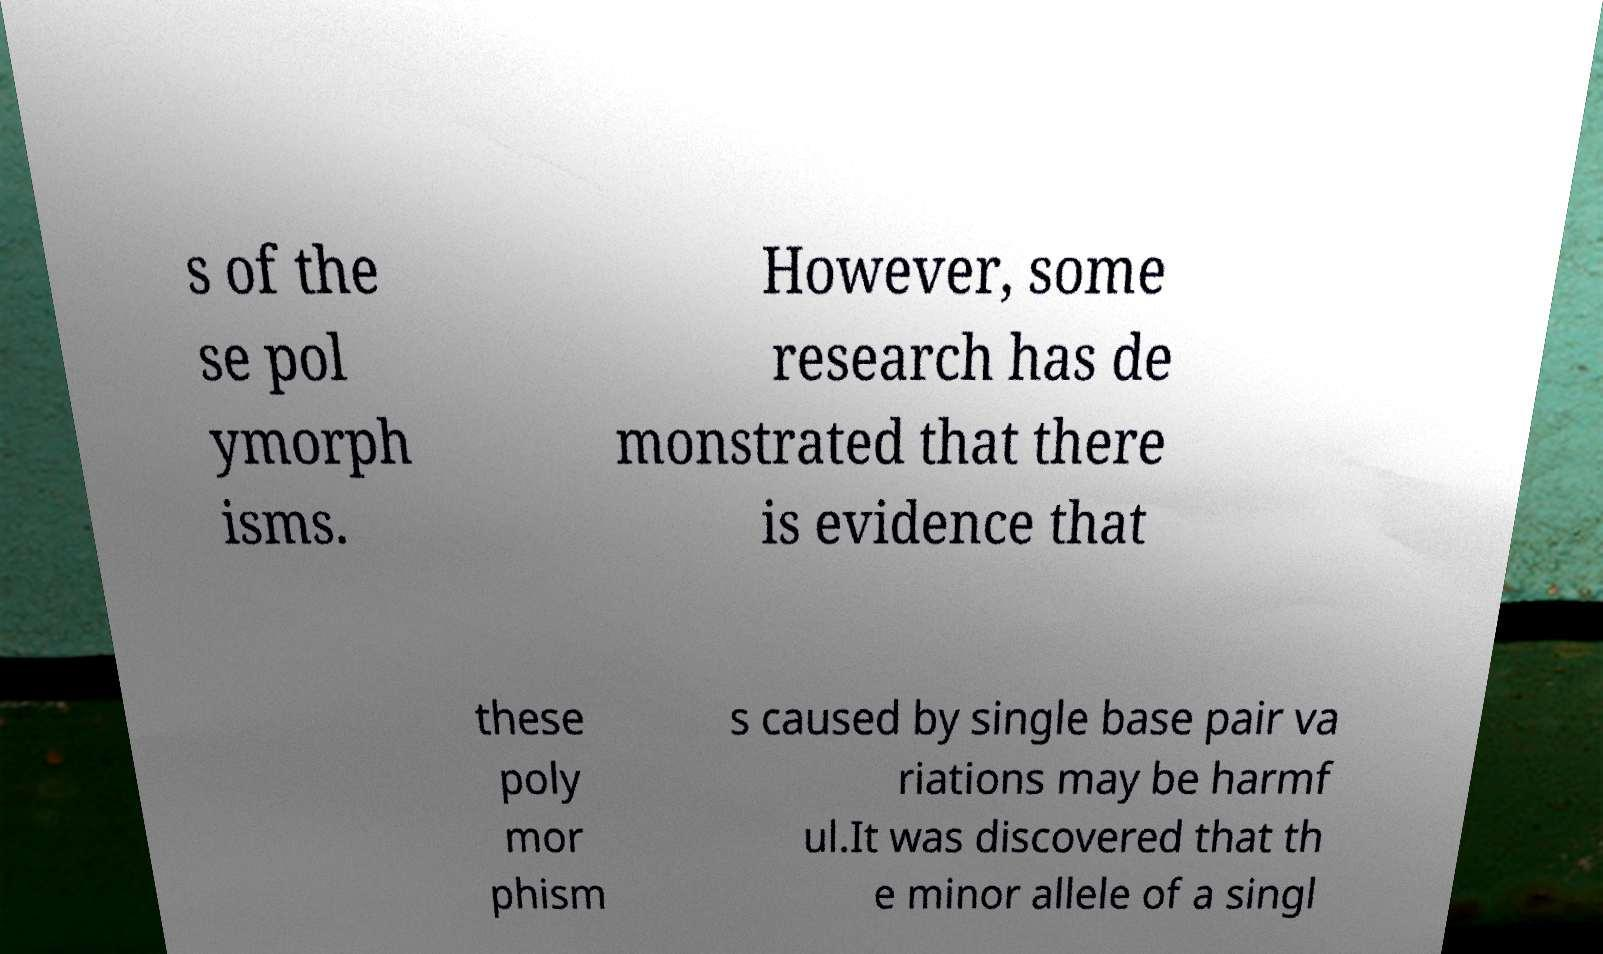What messages or text are displayed in this image? I need them in a readable, typed format. s of the se pol ymorph isms. However, some research has de monstrated that there is evidence that these poly mor phism s caused by single base pair va riations may be harmf ul.It was discovered that th e minor allele of a singl 